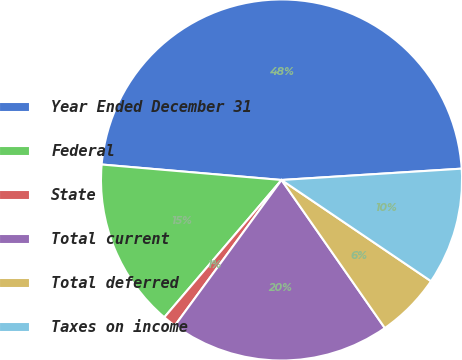<chart> <loc_0><loc_0><loc_500><loc_500><pie_chart><fcel>Year Ended December 31<fcel>Federal<fcel>State<fcel>Total current<fcel>Total deferred<fcel>Taxes on income<nl><fcel>47.63%<fcel>15.12%<fcel>1.18%<fcel>19.76%<fcel>5.83%<fcel>10.47%<nl></chart> 